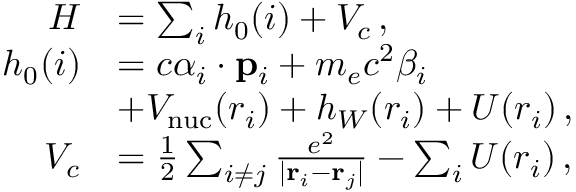<formula> <loc_0><loc_0><loc_500><loc_500>\begin{array} { r l } { H } & { = \sum _ { i } h _ { 0 } ( i ) + V _ { c } \, , } \\ { h _ { 0 } ( i ) } & { = c \alpha _ { i } \cdot { p } _ { i } + m _ { e } c ^ { 2 } \beta _ { i } } \\ & { + V _ { n u c } ( r _ { i } ) + h _ { W } ( r _ { i } ) + U ( r _ { i } ) \, , } \\ { V _ { c } } & { = \frac { 1 } { 2 } \sum _ { i \neq j } \frac { e ^ { 2 } } { | { r } _ { i } - { r } _ { j } | } - \sum _ { i } U ( r _ { i } ) \, , } \end{array}</formula> 